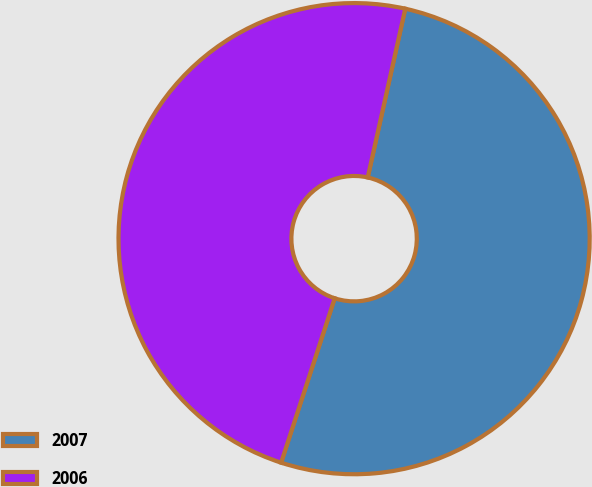Convert chart to OTSL. <chart><loc_0><loc_0><loc_500><loc_500><pie_chart><fcel>2007<fcel>2006<nl><fcel>51.53%<fcel>48.47%<nl></chart> 